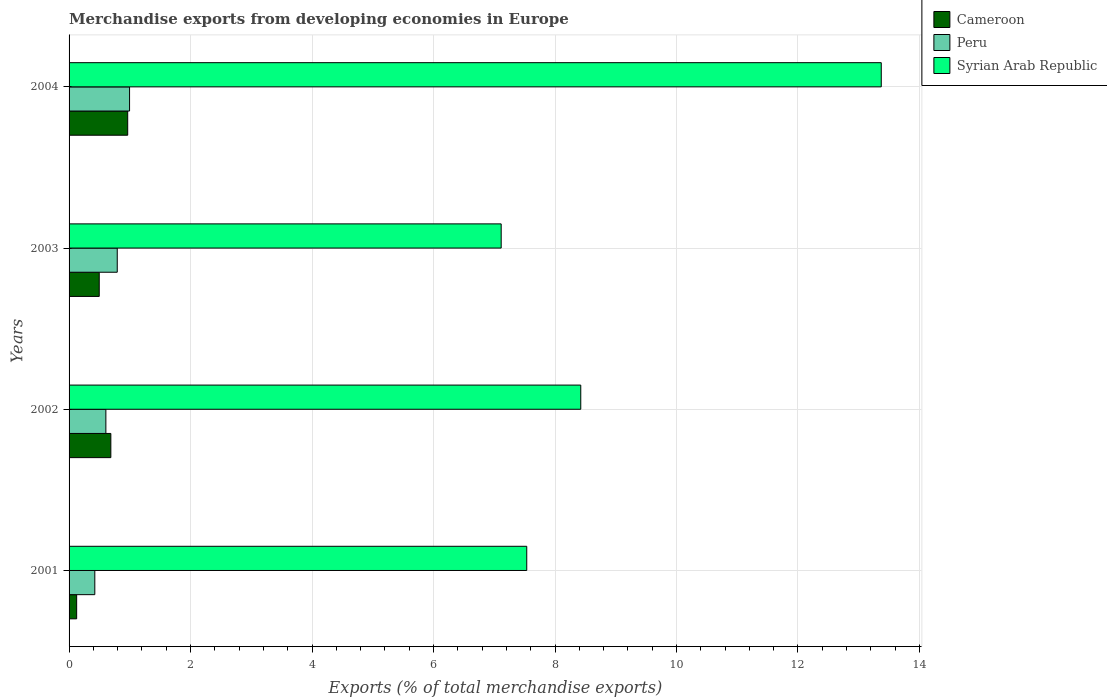What is the label of the 3rd group of bars from the top?
Provide a short and direct response. 2002. What is the percentage of total merchandise exports in Peru in 2004?
Keep it short and to the point. 1. Across all years, what is the maximum percentage of total merchandise exports in Cameroon?
Your answer should be very brief. 0.97. Across all years, what is the minimum percentage of total merchandise exports in Syrian Arab Republic?
Your answer should be compact. 7.11. In which year was the percentage of total merchandise exports in Cameroon maximum?
Keep it short and to the point. 2004. In which year was the percentage of total merchandise exports in Peru minimum?
Your answer should be very brief. 2001. What is the total percentage of total merchandise exports in Peru in the graph?
Your answer should be compact. 2.82. What is the difference between the percentage of total merchandise exports in Cameroon in 2001 and that in 2003?
Ensure brevity in your answer.  -0.37. What is the difference between the percentage of total merchandise exports in Peru in 2003 and the percentage of total merchandise exports in Syrian Arab Republic in 2002?
Your answer should be very brief. -7.63. What is the average percentage of total merchandise exports in Cameroon per year?
Ensure brevity in your answer.  0.57. In the year 2004, what is the difference between the percentage of total merchandise exports in Cameroon and percentage of total merchandise exports in Syrian Arab Republic?
Ensure brevity in your answer.  -12.41. In how many years, is the percentage of total merchandise exports in Syrian Arab Republic greater than 10.4 %?
Give a very brief answer. 1. What is the ratio of the percentage of total merchandise exports in Cameroon in 2002 to that in 2003?
Offer a very short reply. 1.38. Is the difference between the percentage of total merchandise exports in Cameroon in 2002 and 2003 greater than the difference between the percentage of total merchandise exports in Syrian Arab Republic in 2002 and 2003?
Offer a very short reply. No. What is the difference between the highest and the second highest percentage of total merchandise exports in Syrian Arab Republic?
Provide a succinct answer. 4.95. What is the difference between the highest and the lowest percentage of total merchandise exports in Syrian Arab Republic?
Provide a succinct answer. 6.26. In how many years, is the percentage of total merchandise exports in Peru greater than the average percentage of total merchandise exports in Peru taken over all years?
Make the answer very short. 2. Is the sum of the percentage of total merchandise exports in Cameroon in 2002 and 2003 greater than the maximum percentage of total merchandise exports in Peru across all years?
Offer a terse response. Yes. What does the 3rd bar from the bottom in 2002 represents?
Your answer should be very brief. Syrian Arab Republic. Is it the case that in every year, the sum of the percentage of total merchandise exports in Syrian Arab Republic and percentage of total merchandise exports in Cameroon is greater than the percentage of total merchandise exports in Peru?
Ensure brevity in your answer.  Yes. Are all the bars in the graph horizontal?
Offer a very short reply. Yes. How many years are there in the graph?
Provide a short and direct response. 4. Are the values on the major ticks of X-axis written in scientific E-notation?
Ensure brevity in your answer.  No. Does the graph contain grids?
Ensure brevity in your answer.  Yes. How many legend labels are there?
Provide a short and direct response. 3. How are the legend labels stacked?
Your response must be concise. Vertical. What is the title of the graph?
Ensure brevity in your answer.  Merchandise exports from developing economies in Europe. Does "Peru" appear as one of the legend labels in the graph?
Provide a short and direct response. Yes. What is the label or title of the X-axis?
Give a very brief answer. Exports (% of total merchandise exports). What is the label or title of the Y-axis?
Keep it short and to the point. Years. What is the Exports (% of total merchandise exports) in Cameroon in 2001?
Provide a succinct answer. 0.12. What is the Exports (% of total merchandise exports) in Peru in 2001?
Give a very brief answer. 0.42. What is the Exports (% of total merchandise exports) in Syrian Arab Republic in 2001?
Your response must be concise. 7.53. What is the Exports (% of total merchandise exports) of Cameroon in 2002?
Make the answer very short. 0.69. What is the Exports (% of total merchandise exports) of Peru in 2002?
Your answer should be very brief. 0.61. What is the Exports (% of total merchandise exports) of Syrian Arab Republic in 2002?
Give a very brief answer. 8.42. What is the Exports (% of total merchandise exports) of Cameroon in 2003?
Give a very brief answer. 0.5. What is the Exports (% of total merchandise exports) of Peru in 2003?
Offer a terse response. 0.79. What is the Exports (% of total merchandise exports) in Syrian Arab Republic in 2003?
Your response must be concise. 7.11. What is the Exports (% of total merchandise exports) in Cameroon in 2004?
Keep it short and to the point. 0.97. What is the Exports (% of total merchandise exports) of Peru in 2004?
Your answer should be compact. 1. What is the Exports (% of total merchandise exports) in Syrian Arab Republic in 2004?
Your answer should be very brief. 13.37. Across all years, what is the maximum Exports (% of total merchandise exports) in Cameroon?
Provide a short and direct response. 0.97. Across all years, what is the maximum Exports (% of total merchandise exports) in Peru?
Offer a very short reply. 1. Across all years, what is the maximum Exports (% of total merchandise exports) in Syrian Arab Republic?
Make the answer very short. 13.37. Across all years, what is the minimum Exports (% of total merchandise exports) in Cameroon?
Provide a succinct answer. 0.12. Across all years, what is the minimum Exports (% of total merchandise exports) in Peru?
Make the answer very short. 0.42. Across all years, what is the minimum Exports (% of total merchandise exports) of Syrian Arab Republic?
Make the answer very short. 7.11. What is the total Exports (% of total merchandise exports) in Cameroon in the graph?
Your answer should be very brief. 2.27. What is the total Exports (% of total merchandise exports) in Peru in the graph?
Offer a terse response. 2.82. What is the total Exports (% of total merchandise exports) of Syrian Arab Republic in the graph?
Provide a succinct answer. 36.44. What is the difference between the Exports (% of total merchandise exports) of Cameroon in 2001 and that in 2002?
Your response must be concise. -0.56. What is the difference between the Exports (% of total merchandise exports) of Peru in 2001 and that in 2002?
Provide a short and direct response. -0.18. What is the difference between the Exports (% of total merchandise exports) of Syrian Arab Republic in 2001 and that in 2002?
Give a very brief answer. -0.89. What is the difference between the Exports (% of total merchandise exports) of Cameroon in 2001 and that in 2003?
Your answer should be compact. -0.37. What is the difference between the Exports (% of total merchandise exports) of Peru in 2001 and that in 2003?
Make the answer very short. -0.37. What is the difference between the Exports (% of total merchandise exports) of Syrian Arab Republic in 2001 and that in 2003?
Offer a very short reply. 0.42. What is the difference between the Exports (% of total merchandise exports) of Cameroon in 2001 and that in 2004?
Provide a short and direct response. -0.84. What is the difference between the Exports (% of total merchandise exports) of Peru in 2001 and that in 2004?
Offer a very short reply. -0.57. What is the difference between the Exports (% of total merchandise exports) of Syrian Arab Republic in 2001 and that in 2004?
Offer a very short reply. -5.84. What is the difference between the Exports (% of total merchandise exports) of Cameroon in 2002 and that in 2003?
Keep it short and to the point. 0.19. What is the difference between the Exports (% of total merchandise exports) of Peru in 2002 and that in 2003?
Give a very brief answer. -0.19. What is the difference between the Exports (% of total merchandise exports) of Syrian Arab Republic in 2002 and that in 2003?
Provide a short and direct response. 1.31. What is the difference between the Exports (% of total merchandise exports) of Cameroon in 2002 and that in 2004?
Provide a short and direct response. -0.28. What is the difference between the Exports (% of total merchandise exports) of Peru in 2002 and that in 2004?
Provide a short and direct response. -0.39. What is the difference between the Exports (% of total merchandise exports) of Syrian Arab Republic in 2002 and that in 2004?
Make the answer very short. -4.95. What is the difference between the Exports (% of total merchandise exports) in Cameroon in 2003 and that in 2004?
Provide a succinct answer. -0.47. What is the difference between the Exports (% of total merchandise exports) of Peru in 2003 and that in 2004?
Offer a terse response. -0.2. What is the difference between the Exports (% of total merchandise exports) in Syrian Arab Republic in 2003 and that in 2004?
Ensure brevity in your answer.  -6.26. What is the difference between the Exports (% of total merchandise exports) in Cameroon in 2001 and the Exports (% of total merchandise exports) in Peru in 2002?
Keep it short and to the point. -0.48. What is the difference between the Exports (% of total merchandise exports) in Cameroon in 2001 and the Exports (% of total merchandise exports) in Syrian Arab Republic in 2002?
Your answer should be very brief. -8.3. What is the difference between the Exports (% of total merchandise exports) in Peru in 2001 and the Exports (% of total merchandise exports) in Syrian Arab Republic in 2002?
Offer a very short reply. -8. What is the difference between the Exports (% of total merchandise exports) in Cameroon in 2001 and the Exports (% of total merchandise exports) in Peru in 2003?
Provide a short and direct response. -0.67. What is the difference between the Exports (% of total merchandise exports) of Cameroon in 2001 and the Exports (% of total merchandise exports) of Syrian Arab Republic in 2003?
Make the answer very short. -6.99. What is the difference between the Exports (% of total merchandise exports) of Peru in 2001 and the Exports (% of total merchandise exports) of Syrian Arab Republic in 2003?
Offer a terse response. -6.69. What is the difference between the Exports (% of total merchandise exports) of Cameroon in 2001 and the Exports (% of total merchandise exports) of Peru in 2004?
Keep it short and to the point. -0.87. What is the difference between the Exports (% of total merchandise exports) in Cameroon in 2001 and the Exports (% of total merchandise exports) in Syrian Arab Republic in 2004?
Offer a very short reply. -13.25. What is the difference between the Exports (% of total merchandise exports) of Peru in 2001 and the Exports (% of total merchandise exports) of Syrian Arab Republic in 2004?
Make the answer very short. -12.95. What is the difference between the Exports (% of total merchandise exports) in Cameroon in 2002 and the Exports (% of total merchandise exports) in Peru in 2003?
Offer a very short reply. -0.11. What is the difference between the Exports (% of total merchandise exports) of Cameroon in 2002 and the Exports (% of total merchandise exports) of Syrian Arab Republic in 2003?
Offer a terse response. -6.43. What is the difference between the Exports (% of total merchandise exports) of Peru in 2002 and the Exports (% of total merchandise exports) of Syrian Arab Republic in 2003?
Offer a very short reply. -6.51. What is the difference between the Exports (% of total merchandise exports) in Cameroon in 2002 and the Exports (% of total merchandise exports) in Peru in 2004?
Give a very brief answer. -0.31. What is the difference between the Exports (% of total merchandise exports) in Cameroon in 2002 and the Exports (% of total merchandise exports) in Syrian Arab Republic in 2004?
Ensure brevity in your answer.  -12.68. What is the difference between the Exports (% of total merchandise exports) of Peru in 2002 and the Exports (% of total merchandise exports) of Syrian Arab Republic in 2004?
Offer a terse response. -12.76. What is the difference between the Exports (% of total merchandise exports) of Cameroon in 2003 and the Exports (% of total merchandise exports) of Peru in 2004?
Keep it short and to the point. -0.5. What is the difference between the Exports (% of total merchandise exports) in Cameroon in 2003 and the Exports (% of total merchandise exports) in Syrian Arab Republic in 2004?
Provide a succinct answer. -12.87. What is the difference between the Exports (% of total merchandise exports) of Peru in 2003 and the Exports (% of total merchandise exports) of Syrian Arab Republic in 2004?
Ensure brevity in your answer.  -12.58. What is the average Exports (% of total merchandise exports) of Cameroon per year?
Provide a succinct answer. 0.57. What is the average Exports (% of total merchandise exports) in Peru per year?
Your response must be concise. 0.7. What is the average Exports (% of total merchandise exports) in Syrian Arab Republic per year?
Keep it short and to the point. 9.11. In the year 2001, what is the difference between the Exports (% of total merchandise exports) in Cameroon and Exports (% of total merchandise exports) in Peru?
Offer a very short reply. -0.3. In the year 2001, what is the difference between the Exports (% of total merchandise exports) of Cameroon and Exports (% of total merchandise exports) of Syrian Arab Republic?
Your answer should be compact. -7.41. In the year 2001, what is the difference between the Exports (% of total merchandise exports) in Peru and Exports (% of total merchandise exports) in Syrian Arab Republic?
Your response must be concise. -7.11. In the year 2002, what is the difference between the Exports (% of total merchandise exports) in Cameroon and Exports (% of total merchandise exports) in Peru?
Your answer should be very brief. 0.08. In the year 2002, what is the difference between the Exports (% of total merchandise exports) in Cameroon and Exports (% of total merchandise exports) in Syrian Arab Republic?
Provide a short and direct response. -7.74. In the year 2002, what is the difference between the Exports (% of total merchandise exports) of Peru and Exports (% of total merchandise exports) of Syrian Arab Republic?
Your answer should be compact. -7.82. In the year 2003, what is the difference between the Exports (% of total merchandise exports) in Cameroon and Exports (% of total merchandise exports) in Peru?
Keep it short and to the point. -0.3. In the year 2003, what is the difference between the Exports (% of total merchandise exports) of Cameroon and Exports (% of total merchandise exports) of Syrian Arab Republic?
Ensure brevity in your answer.  -6.62. In the year 2003, what is the difference between the Exports (% of total merchandise exports) in Peru and Exports (% of total merchandise exports) in Syrian Arab Republic?
Your answer should be compact. -6.32. In the year 2004, what is the difference between the Exports (% of total merchandise exports) in Cameroon and Exports (% of total merchandise exports) in Peru?
Your answer should be compact. -0.03. In the year 2004, what is the difference between the Exports (% of total merchandise exports) of Cameroon and Exports (% of total merchandise exports) of Syrian Arab Republic?
Ensure brevity in your answer.  -12.41. In the year 2004, what is the difference between the Exports (% of total merchandise exports) in Peru and Exports (% of total merchandise exports) in Syrian Arab Republic?
Offer a very short reply. -12.38. What is the ratio of the Exports (% of total merchandise exports) of Cameroon in 2001 to that in 2002?
Offer a terse response. 0.18. What is the ratio of the Exports (% of total merchandise exports) of Peru in 2001 to that in 2002?
Make the answer very short. 0.7. What is the ratio of the Exports (% of total merchandise exports) of Syrian Arab Republic in 2001 to that in 2002?
Offer a terse response. 0.89. What is the ratio of the Exports (% of total merchandise exports) in Cameroon in 2001 to that in 2003?
Keep it short and to the point. 0.25. What is the ratio of the Exports (% of total merchandise exports) of Peru in 2001 to that in 2003?
Your answer should be very brief. 0.53. What is the ratio of the Exports (% of total merchandise exports) of Syrian Arab Republic in 2001 to that in 2003?
Give a very brief answer. 1.06. What is the ratio of the Exports (% of total merchandise exports) of Cameroon in 2001 to that in 2004?
Ensure brevity in your answer.  0.13. What is the ratio of the Exports (% of total merchandise exports) of Peru in 2001 to that in 2004?
Give a very brief answer. 0.43. What is the ratio of the Exports (% of total merchandise exports) in Syrian Arab Republic in 2001 to that in 2004?
Make the answer very short. 0.56. What is the ratio of the Exports (% of total merchandise exports) of Cameroon in 2002 to that in 2003?
Offer a terse response. 1.38. What is the ratio of the Exports (% of total merchandise exports) in Peru in 2002 to that in 2003?
Keep it short and to the point. 0.76. What is the ratio of the Exports (% of total merchandise exports) of Syrian Arab Republic in 2002 to that in 2003?
Provide a succinct answer. 1.18. What is the ratio of the Exports (% of total merchandise exports) of Cameroon in 2002 to that in 2004?
Give a very brief answer. 0.71. What is the ratio of the Exports (% of total merchandise exports) in Peru in 2002 to that in 2004?
Make the answer very short. 0.61. What is the ratio of the Exports (% of total merchandise exports) of Syrian Arab Republic in 2002 to that in 2004?
Provide a succinct answer. 0.63. What is the ratio of the Exports (% of total merchandise exports) of Cameroon in 2003 to that in 2004?
Keep it short and to the point. 0.51. What is the ratio of the Exports (% of total merchandise exports) in Peru in 2003 to that in 2004?
Provide a succinct answer. 0.8. What is the ratio of the Exports (% of total merchandise exports) of Syrian Arab Republic in 2003 to that in 2004?
Give a very brief answer. 0.53. What is the difference between the highest and the second highest Exports (% of total merchandise exports) of Cameroon?
Your answer should be very brief. 0.28. What is the difference between the highest and the second highest Exports (% of total merchandise exports) of Peru?
Make the answer very short. 0.2. What is the difference between the highest and the second highest Exports (% of total merchandise exports) of Syrian Arab Republic?
Your answer should be compact. 4.95. What is the difference between the highest and the lowest Exports (% of total merchandise exports) in Cameroon?
Your answer should be very brief. 0.84. What is the difference between the highest and the lowest Exports (% of total merchandise exports) of Peru?
Make the answer very short. 0.57. What is the difference between the highest and the lowest Exports (% of total merchandise exports) in Syrian Arab Republic?
Offer a very short reply. 6.26. 